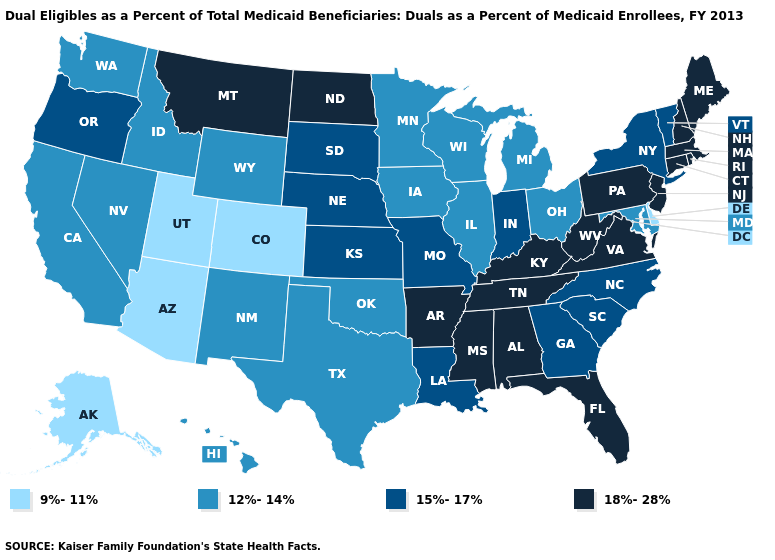Does Ohio have the highest value in the MidWest?
Give a very brief answer. No. Which states have the lowest value in the MidWest?
Quick response, please. Illinois, Iowa, Michigan, Minnesota, Ohio, Wisconsin. What is the value of New Mexico?
Quick response, please. 12%-14%. What is the value of Virginia?
Be succinct. 18%-28%. What is the lowest value in states that border Wyoming?
Short answer required. 9%-11%. What is the value of New Jersey?
Be succinct. 18%-28%. Does the map have missing data?
Short answer required. No. Which states have the lowest value in the USA?
Write a very short answer. Alaska, Arizona, Colorado, Delaware, Utah. Does Maine have the highest value in the USA?
Short answer required. Yes. How many symbols are there in the legend?
Keep it brief. 4. Name the states that have a value in the range 12%-14%?
Short answer required. California, Hawaii, Idaho, Illinois, Iowa, Maryland, Michigan, Minnesota, Nevada, New Mexico, Ohio, Oklahoma, Texas, Washington, Wisconsin, Wyoming. What is the value of West Virginia?
Concise answer only. 18%-28%. Does New York have a lower value than New Hampshire?
Short answer required. Yes. Name the states that have a value in the range 15%-17%?
Be succinct. Georgia, Indiana, Kansas, Louisiana, Missouri, Nebraska, New York, North Carolina, Oregon, South Carolina, South Dakota, Vermont. 